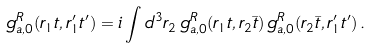Convert formula to latex. <formula><loc_0><loc_0><loc_500><loc_500>g _ { a , 0 } ^ { R } ( { r } _ { 1 } t , { r } _ { 1 } ^ { \prime } t ^ { \prime } ) = i \int d ^ { 3 } r _ { 2 } \, g _ { a , 0 } ^ { R } ( { r } _ { 1 } t , { r } _ { 2 } { \bar { t } } ) \, g _ { a , 0 } ^ { R } ( { r } _ { 2 } { \bar { t } } , { r } _ { 1 } ^ { \prime } t ^ { \prime } ) \, .</formula> 